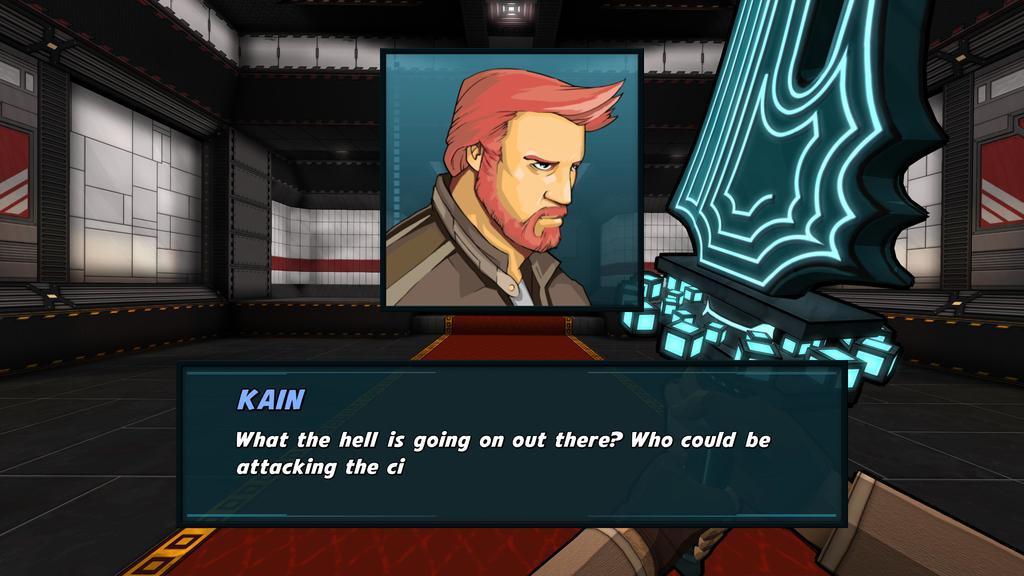Please provide a concise description of this image. In this animated image I can see a person's hand, a person's face, walls, object and carpet.   